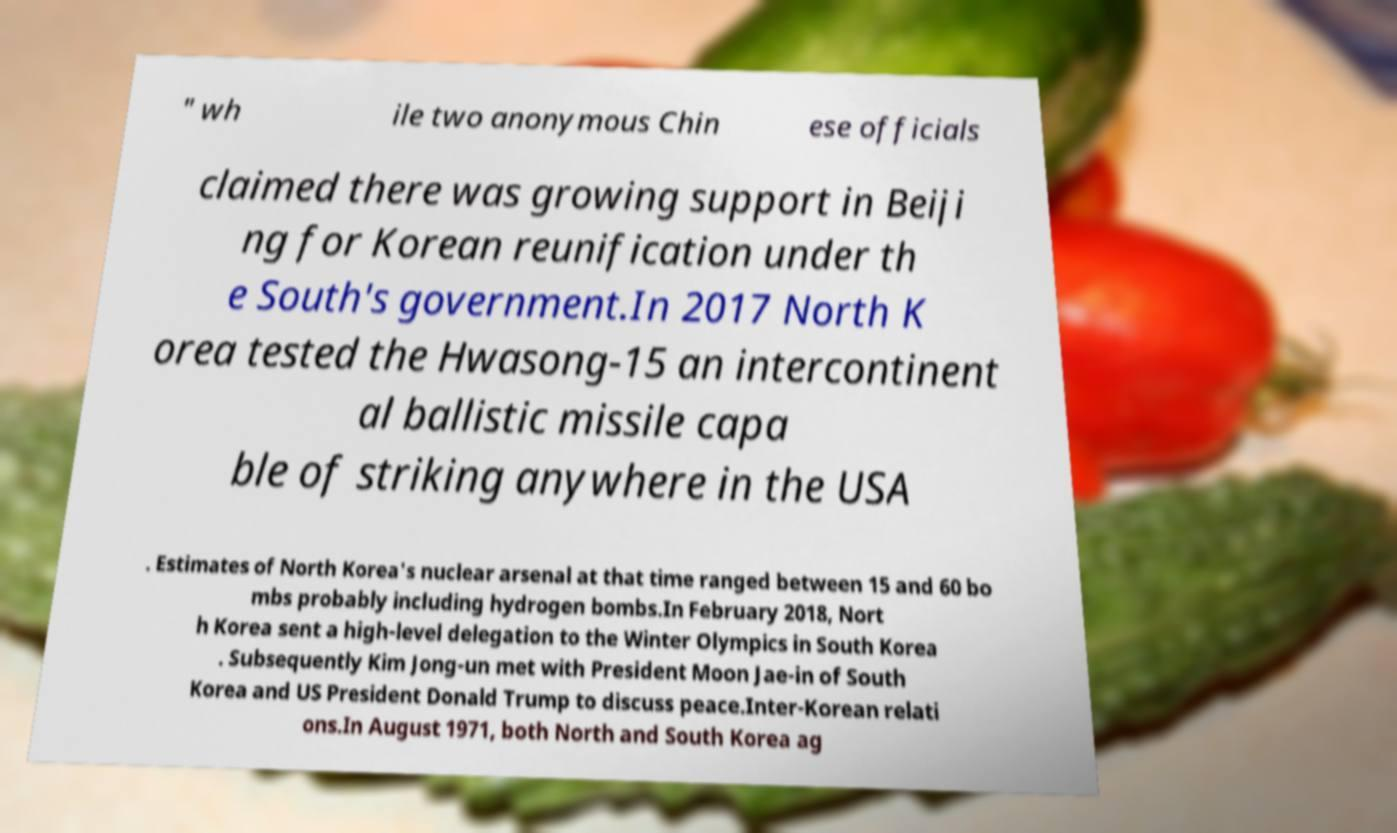Could you assist in decoding the text presented in this image and type it out clearly? " wh ile two anonymous Chin ese officials claimed there was growing support in Beiji ng for Korean reunification under th e South's government.In 2017 North K orea tested the Hwasong-15 an intercontinent al ballistic missile capa ble of striking anywhere in the USA . Estimates of North Korea's nuclear arsenal at that time ranged between 15 and 60 bo mbs probably including hydrogen bombs.In February 2018, Nort h Korea sent a high-level delegation to the Winter Olympics in South Korea . Subsequently Kim Jong-un met with President Moon Jae-in of South Korea and US President Donald Trump to discuss peace.Inter-Korean relati ons.In August 1971, both North and South Korea ag 